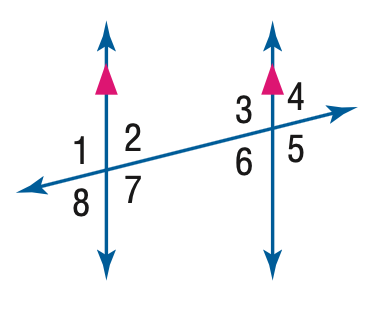Answer the mathemtical geometry problem and directly provide the correct option letter.
Question: In the figure, m \angle 1 = 94. Find the measure of \angle 5.
Choices: A: 76 B: 86 C: 94 D: 96 C 